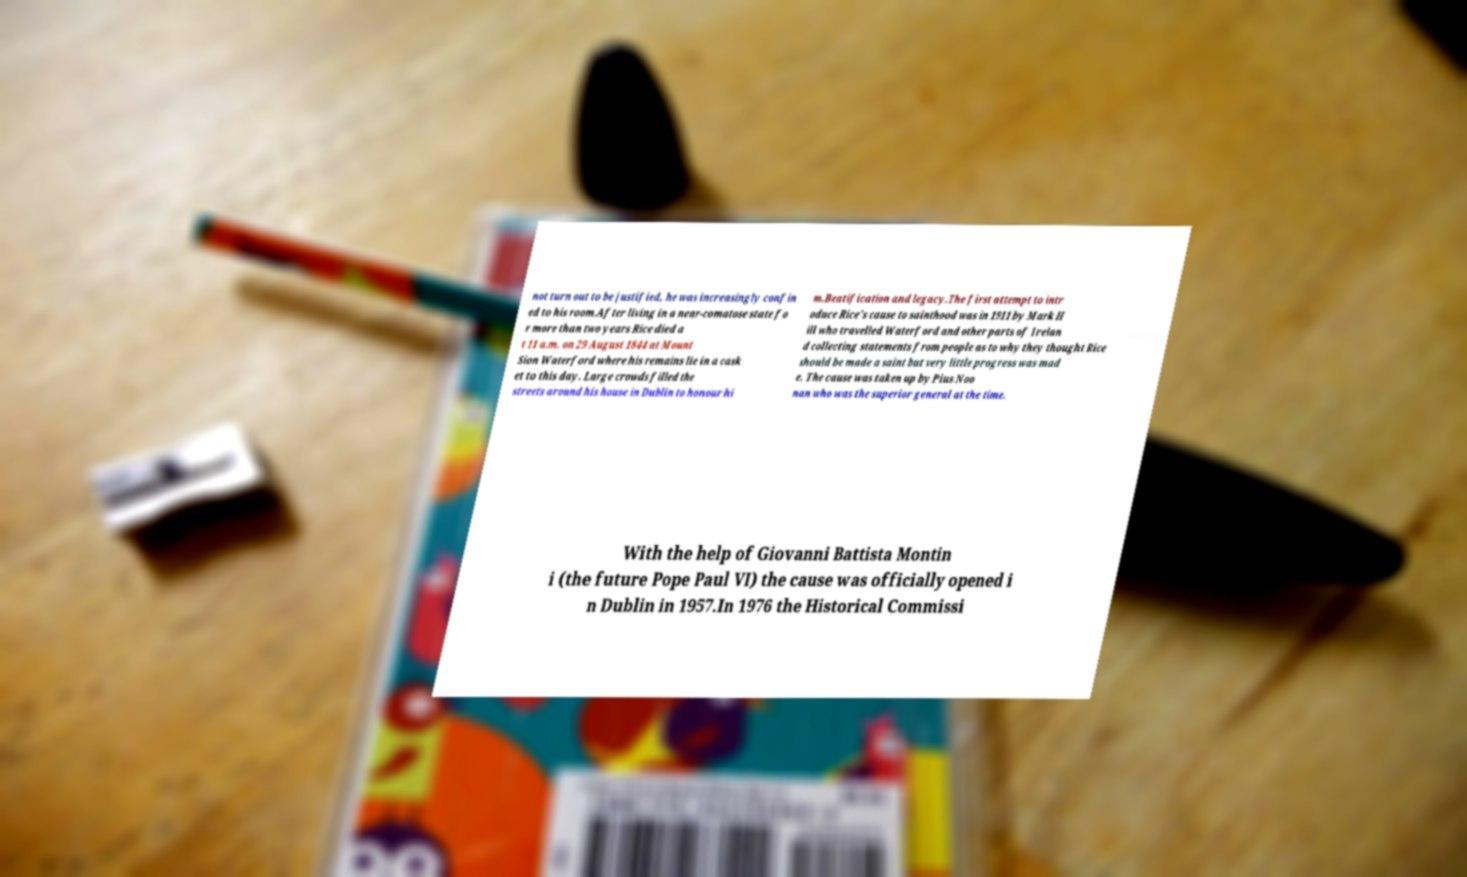Could you extract and type out the text from this image? not turn out to be justified, he was increasingly confin ed to his room.After living in a near-comatose state fo r more than two years Rice died a t 11 a.m. on 29 August 1844 at Mount Sion Waterford where his remains lie in a cask et to this day. Large crowds filled the streets around his house in Dublin to honour hi m.Beatification and legacy.The first attempt to intr oduce Rice's cause to sainthood was in 1911 by Mark H ill who travelled Waterford and other parts of Irelan d collecting statements from people as to why they thought Rice should be made a saint but very little progress was mad e. The cause was taken up by Pius Noo nan who was the superior general at the time. With the help of Giovanni Battista Montin i (the future Pope Paul VI) the cause was officially opened i n Dublin in 1957.In 1976 the Historical Commissi 